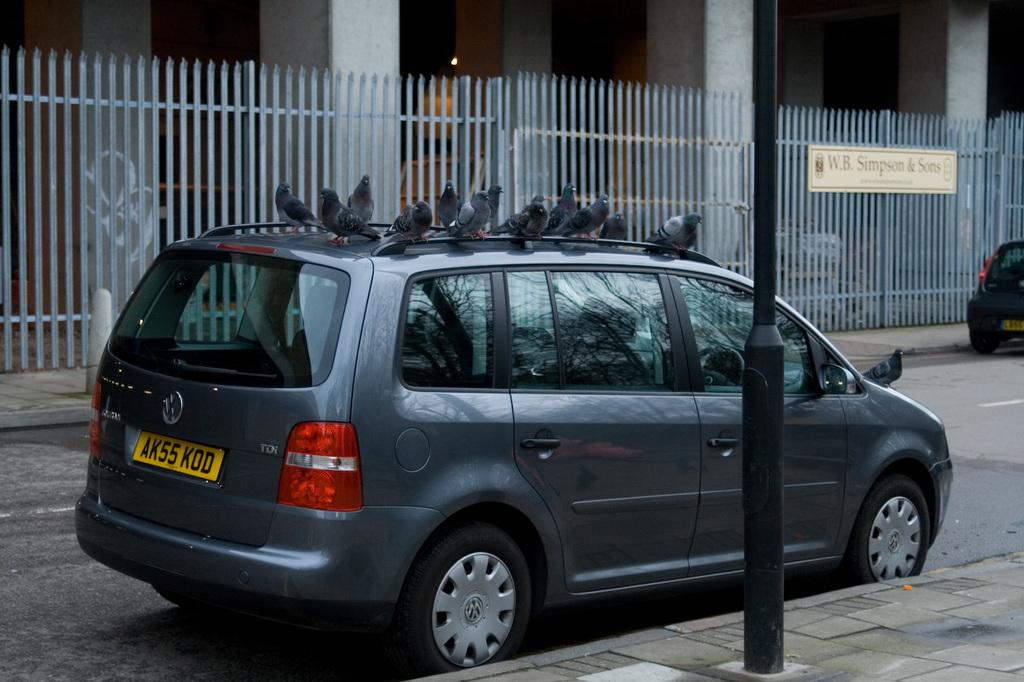<image>
Summarize the visual content of the image. a van that has the letters AK on the back 